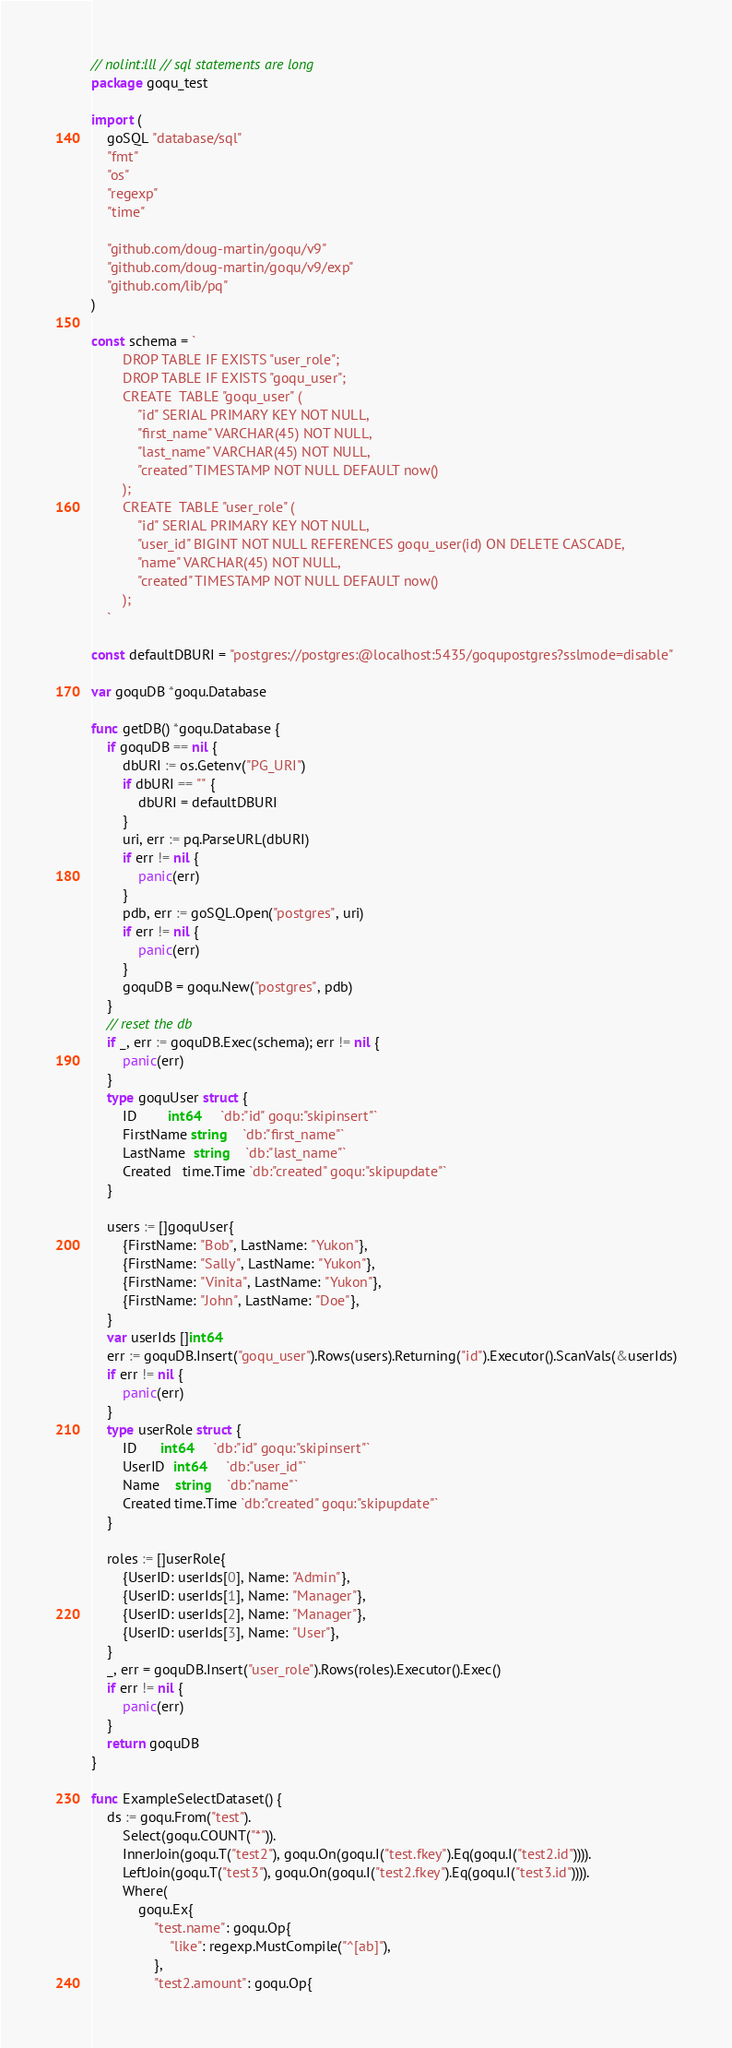<code> <loc_0><loc_0><loc_500><loc_500><_Go_>// nolint:lll // sql statements are long
package goqu_test

import (
	goSQL "database/sql"
	"fmt"
	"os"
	"regexp"
	"time"

	"github.com/doug-martin/goqu/v9"
	"github.com/doug-martin/goqu/v9/exp"
	"github.com/lib/pq"
)

const schema = `
		DROP TABLE IF EXISTS "user_role";
		DROP TABLE IF EXISTS "goqu_user";	
		CREATE  TABLE "goqu_user" (
			"id" SERIAL PRIMARY KEY NOT NULL,
			"first_name" VARCHAR(45) NOT NULL,
			"last_name" VARCHAR(45) NOT NULL,
			"created" TIMESTAMP NOT NULL DEFAULT now()
		);
		CREATE  TABLE "user_role" (
			"id" SERIAL PRIMARY KEY NOT NULL,
			"user_id" BIGINT NOT NULL REFERENCES goqu_user(id) ON DELETE CASCADE,
			"name" VARCHAR(45) NOT NULL,
			"created" TIMESTAMP NOT NULL DEFAULT now()
		); 
    `

const defaultDBURI = "postgres://postgres:@localhost:5435/goqupostgres?sslmode=disable"

var goquDB *goqu.Database

func getDB() *goqu.Database {
	if goquDB == nil {
		dbURI := os.Getenv("PG_URI")
		if dbURI == "" {
			dbURI = defaultDBURI
		}
		uri, err := pq.ParseURL(dbURI)
		if err != nil {
			panic(err)
		}
		pdb, err := goSQL.Open("postgres", uri)
		if err != nil {
			panic(err)
		}
		goquDB = goqu.New("postgres", pdb)
	}
	// reset the db
	if _, err := goquDB.Exec(schema); err != nil {
		panic(err)
	}
	type goquUser struct {
		ID        int64     `db:"id" goqu:"skipinsert"`
		FirstName string    `db:"first_name"`
		LastName  string    `db:"last_name"`
		Created   time.Time `db:"created" goqu:"skipupdate"`
	}

	users := []goquUser{
		{FirstName: "Bob", LastName: "Yukon"},
		{FirstName: "Sally", LastName: "Yukon"},
		{FirstName: "Vinita", LastName: "Yukon"},
		{FirstName: "John", LastName: "Doe"},
	}
	var userIds []int64
	err := goquDB.Insert("goqu_user").Rows(users).Returning("id").Executor().ScanVals(&userIds)
	if err != nil {
		panic(err)
	}
	type userRole struct {
		ID      int64     `db:"id" goqu:"skipinsert"`
		UserID  int64     `db:"user_id"`
		Name    string    `db:"name"`
		Created time.Time `db:"created" goqu:"skipupdate"`
	}

	roles := []userRole{
		{UserID: userIds[0], Name: "Admin"},
		{UserID: userIds[1], Name: "Manager"},
		{UserID: userIds[2], Name: "Manager"},
		{UserID: userIds[3], Name: "User"},
	}
	_, err = goquDB.Insert("user_role").Rows(roles).Executor().Exec()
	if err != nil {
		panic(err)
	}
	return goquDB
}

func ExampleSelectDataset() {
	ds := goqu.From("test").
		Select(goqu.COUNT("*")).
		InnerJoin(goqu.T("test2"), goqu.On(goqu.I("test.fkey").Eq(goqu.I("test2.id")))).
		LeftJoin(goqu.T("test3"), goqu.On(goqu.I("test2.fkey").Eq(goqu.I("test3.id")))).
		Where(
			goqu.Ex{
				"test.name": goqu.Op{
					"like": regexp.MustCompile("^[ab]"),
				},
				"test2.amount": goqu.Op{</code> 